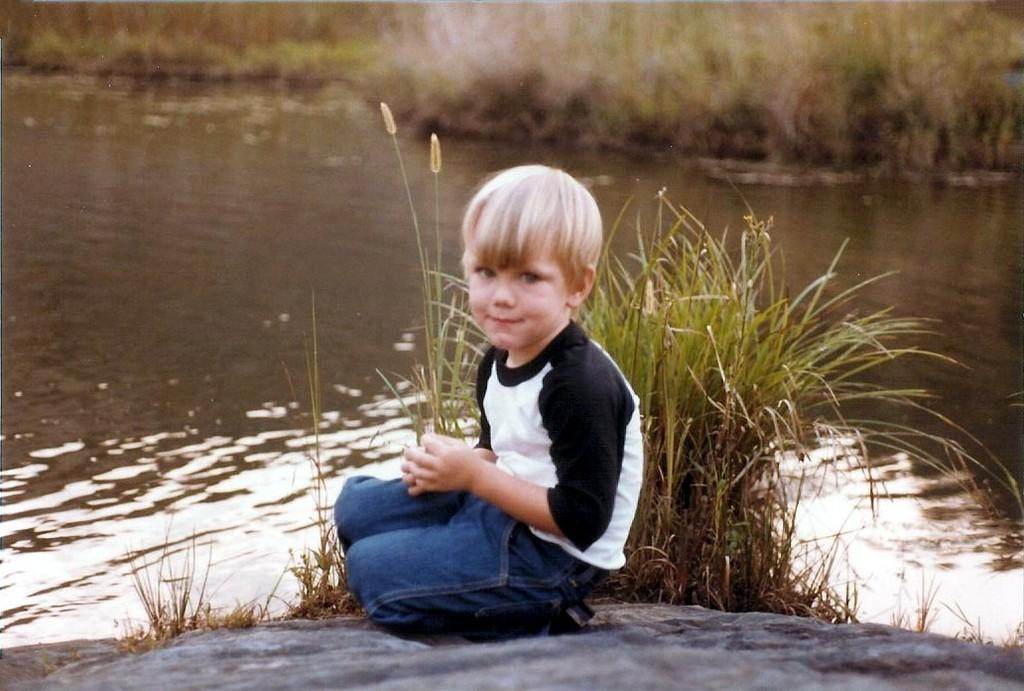What is the main subject of the image? There is a boy sitting in the image. What can be seen in the background of the image? The background of the image is blurred. What type of natural environment is visible in the image? There is water and grass visible in the image. How many frogs can be seen jumping in the water in the image? There are no frogs visible in the image; it features a boy sitting and a blurred background. What type of berry is being turned into a pie in the image? There is no berry or pie present in the image. 